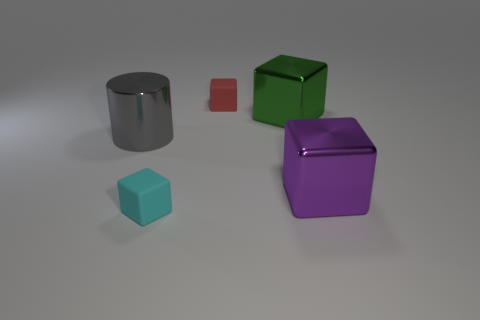The other metal object that is the same shape as the purple shiny thing is what color?
Make the answer very short. Green. There is a big gray metal thing; is its shape the same as the tiny object in front of the large purple metal object?
Your response must be concise. No. What number of objects are either blocks behind the purple block or small matte things that are on the right side of the tiny cyan rubber block?
Keep it short and to the point. 2. What is the big purple cube made of?
Provide a short and direct response. Metal. How many other things are the same size as the cyan block?
Provide a short and direct response. 1. What is the size of the matte block that is to the right of the cyan matte block?
Your answer should be very brief. Small. What is the small thing behind the tiny block that is in front of the rubber object behind the cylinder made of?
Offer a very short reply. Rubber. Do the green metallic object and the cyan matte object have the same shape?
Make the answer very short. Yes. What number of metallic objects are big cylinders or big green objects?
Your answer should be very brief. 2. What number of big green blocks are there?
Give a very brief answer. 1. 